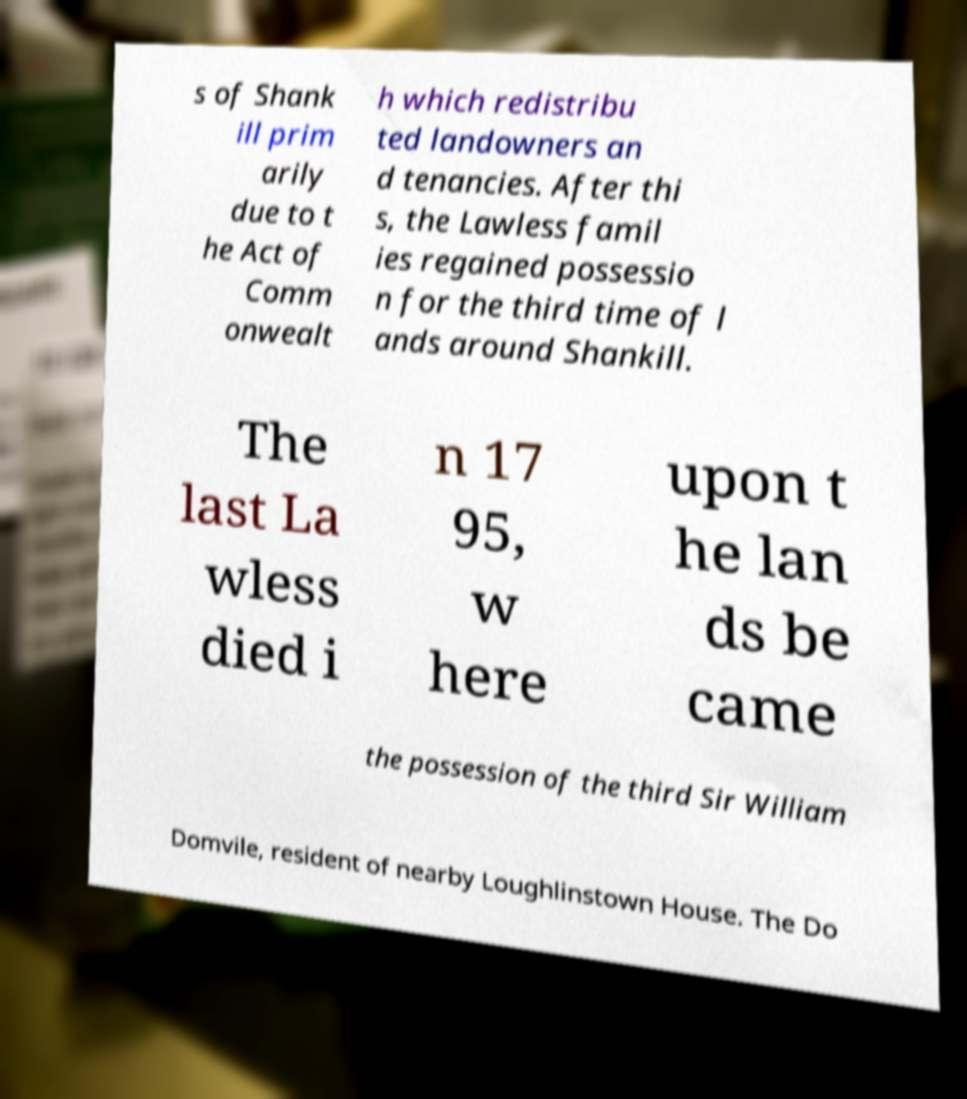Could you assist in decoding the text presented in this image and type it out clearly? s of Shank ill prim arily due to t he Act of Comm onwealt h which redistribu ted landowners an d tenancies. After thi s, the Lawless famil ies regained possessio n for the third time of l ands around Shankill. The last La wless died i n 17 95, w here upon t he lan ds be came the possession of the third Sir William Domvile, resident of nearby Loughlinstown House. The Do 